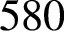<formula> <loc_0><loc_0><loc_500><loc_500>5 8 0</formula> 